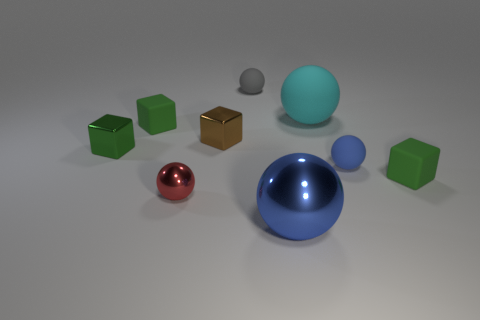Subtract all green cubes. How many were subtracted if there are1green cubes left? 2 Subtract all purple spheres. How many green cubes are left? 3 Subtract all red balls. How many balls are left? 4 Subtract all purple spheres. Subtract all red blocks. How many spheres are left? 5 Add 1 blue metallic things. How many objects exist? 10 Subtract all cubes. How many objects are left? 5 Subtract 0 yellow cubes. How many objects are left? 9 Subtract all purple shiny blocks. Subtract all gray matte objects. How many objects are left? 8 Add 8 matte blocks. How many matte blocks are left? 10 Add 7 big cyan blocks. How many big cyan blocks exist? 7 